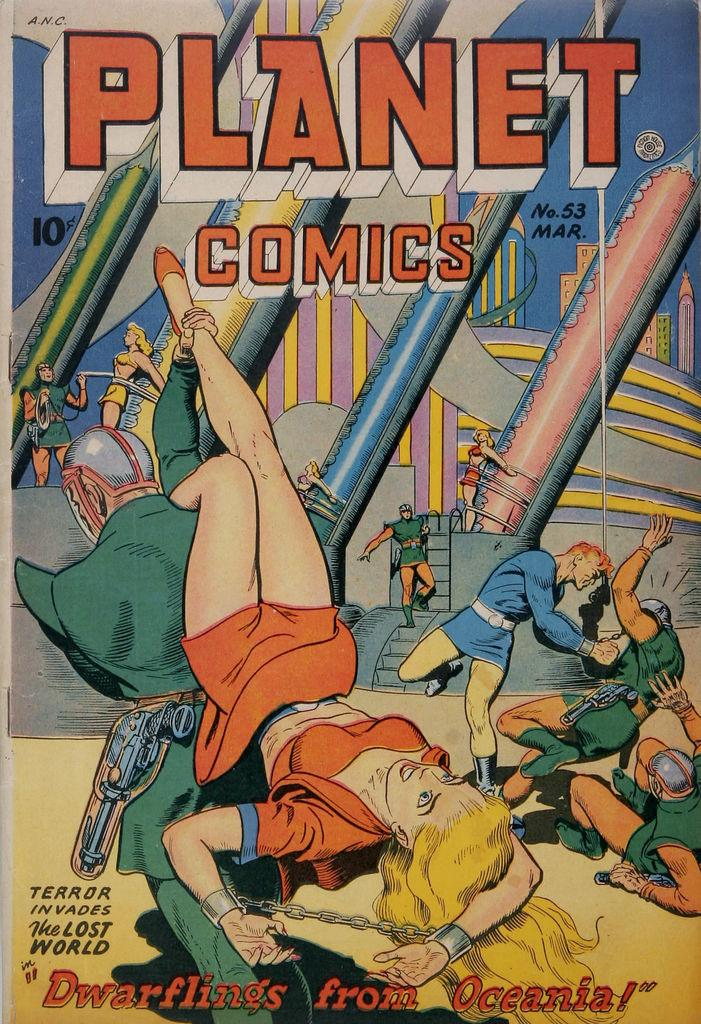<image>
Create a compact narrative representing the image presented. Planet Comics released issue 53 in March and it cost 10 cents to purchase 